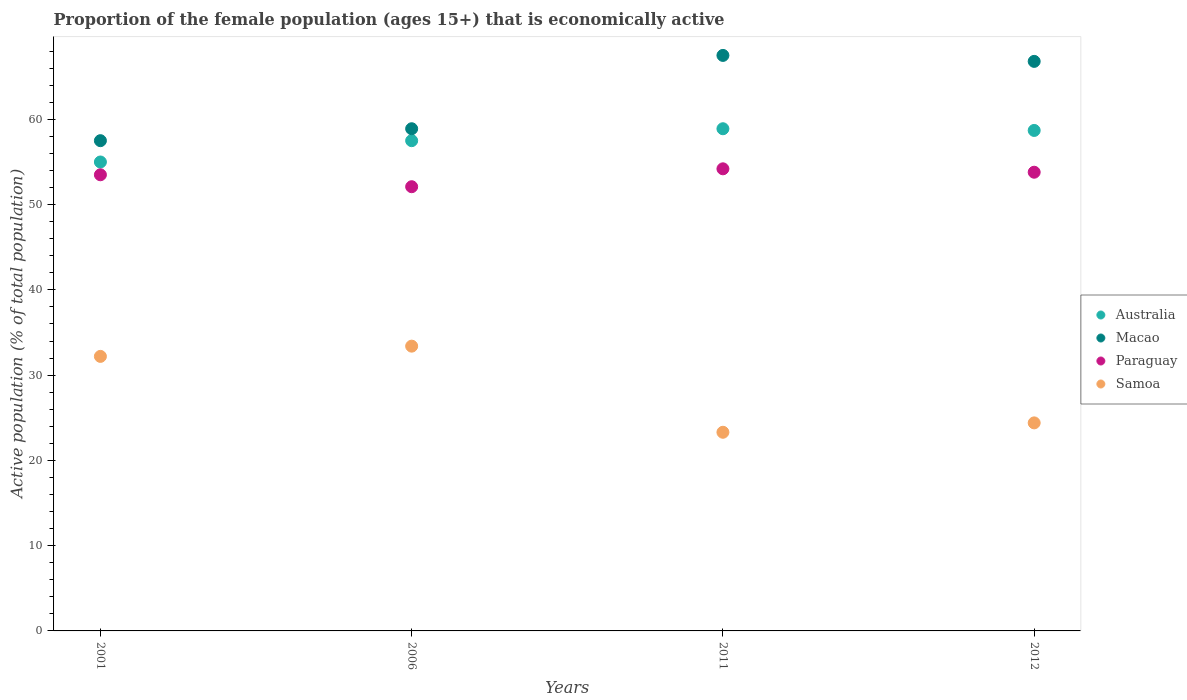How many different coloured dotlines are there?
Your answer should be very brief. 4. Is the number of dotlines equal to the number of legend labels?
Give a very brief answer. Yes. What is the proportion of the female population that is economically active in Samoa in 2006?
Ensure brevity in your answer.  33.4. Across all years, what is the maximum proportion of the female population that is economically active in Macao?
Your answer should be very brief. 67.5. Across all years, what is the minimum proportion of the female population that is economically active in Macao?
Make the answer very short. 57.5. What is the total proportion of the female population that is economically active in Paraguay in the graph?
Your answer should be compact. 213.6. What is the difference between the proportion of the female population that is economically active in Paraguay in 2006 and that in 2012?
Offer a very short reply. -1.7. What is the difference between the proportion of the female population that is economically active in Samoa in 2006 and the proportion of the female population that is economically active in Paraguay in 2001?
Your answer should be very brief. -20.1. What is the average proportion of the female population that is economically active in Paraguay per year?
Provide a succinct answer. 53.4. In the year 2011, what is the difference between the proportion of the female population that is economically active in Macao and proportion of the female population that is economically active in Australia?
Provide a short and direct response. 8.6. What is the ratio of the proportion of the female population that is economically active in Australia in 2006 to that in 2012?
Offer a very short reply. 0.98. Is the difference between the proportion of the female population that is economically active in Macao in 2001 and 2006 greater than the difference between the proportion of the female population that is economically active in Australia in 2001 and 2006?
Keep it short and to the point. Yes. What is the difference between the highest and the second highest proportion of the female population that is economically active in Samoa?
Your answer should be very brief. 1.2. What is the difference between the highest and the lowest proportion of the female population that is economically active in Samoa?
Your response must be concise. 10.1. Is it the case that in every year, the sum of the proportion of the female population that is economically active in Paraguay and proportion of the female population that is economically active in Macao  is greater than the sum of proportion of the female population that is economically active in Australia and proportion of the female population that is economically active in Samoa?
Provide a succinct answer. No. Does the proportion of the female population that is economically active in Samoa monotonically increase over the years?
Provide a succinct answer. No. Is the proportion of the female population that is economically active in Paraguay strictly greater than the proportion of the female population that is economically active in Australia over the years?
Offer a very short reply. No. Is the proportion of the female population that is economically active in Paraguay strictly less than the proportion of the female population that is economically active in Australia over the years?
Make the answer very short. Yes. How many years are there in the graph?
Your response must be concise. 4. What is the difference between two consecutive major ticks on the Y-axis?
Your response must be concise. 10. Are the values on the major ticks of Y-axis written in scientific E-notation?
Give a very brief answer. No. Where does the legend appear in the graph?
Your answer should be compact. Center right. How many legend labels are there?
Provide a succinct answer. 4. What is the title of the graph?
Your answer should be compact. Proportion of the female population (ages 15+) that is economically active. What is the label or title of the X-axis?
Offer a terse response. Years. What is the label or title of the Y-axis?
Your response must be concise. Active population (% of total population). What is the Active population (% of total population) in Australia in 2001?
Provide a succinct answer. 55. What is the Active population (% of total population) in Macao in 2001?
Provide a short and direct response. 57.5. What is the Active population (% of total population) of Paraguay in 2001?
Keep it short and to the point. 53.5. What is the Active population (% of total population) of Samoa in 2001?
Your answer should be very brief. 32.2. What is the Active population (% of total population) of Australia in 2006?
Provide a succinct answer. 57.5. What is the Active population (% of total population) in Macao in 2006?
Offer a terse response. 58.9. What is the Active population (% of total population) of Paraguay in 2006?
Provide a succinct answer. 52.1. What is the Active population (% of total population) of Samoa in 2006?
Make the answer very short. 33.4. What is the Active population (% of total population) of Australia in 2011?
Make the answer very short. 58.9. What is the Active population (% of total population) in Macao in 2011?
Make the answer very short. 67.5. What is the Active population (% of total population) in Paraguay in 2011?
Offer a very short reply. 54.2. What is the Active population (% of total population) of Samoa in 2011?
Your answer should be compact. 23.3. What is the Active population (% of total population) of Australia in 2012?
Ensure brevity in your answer.  58.7. What is the Active population (% of total population) of Macao in 2012?
Give a very brief answer. 66.8. What is the Active population (% of total population) of Paraguay in 2012?
Provide a succinct answer. 53.8. What is the Active population (% of total population) of Samoa in 2012?
Your answer should be compact. 24.4. Across all years, what is the maximum Active population (% of total population) in Australia?
Provide a short and direct response. 58.9. Across all years, what is the maximum Active population (% of total population) in Macao?
Your response must be concise. 67.5. Across all years, what is the maximum Active population (% of total population) of Paraguay?
Your answer should be very brief. 54.2. Across all years, what is the maximum Active population (% of total population) in Samoa?
Offer a very short reply. 33.4. Across all years, what is the minimum Active population (% of total population) in Macao?
Ensure brevity in your answer.  57.5. Across all years, what is the minimum Active population (% of total population) of Paraguay?
Offer a very short reply. 52.1. Across all years, what is the minimum Active population (% of total population) in Samoa?
Offer a terse response. 23.3. What is the total Active population (% of total population) in Australia in the graph?
Make the answer very short. 230.1. What is the total Active population (% of total population) in Macao in the graph?
Keep it short and to the point. 250.7. What is the total Active population (% of total population) of Paraguay in the graph?
Offer a terse response. 213.6. What is the total Active population (% of total population) of Samoa in the graph?
Provide a succinct answer. 113.3. What is the difference between the Active population (% of total population) of Macao in 2001 and that in 2011?
Your answer should be very brief. -10. What is the difference between the Active population (% of total population) in Samoa in 2001 and that in 2011?
Make the answer very short. 8.9. What is the difference between the Active population (% of total population) of Australia in 2001 and that in 2012?
Make the answer very short. -3.7. What is the difference between the Active population (% of total population) in Macao in 2006 and that in 2011?
Keep it short and to the point. -8.6. What is the difference between the Active population (% of total population) in Samoa in 2006 and that in 2011?
Offer a terse response. 10.1. What is the difference between the Active population (% of total population) in Australia in 2006 and that in 2012?
Your answer should be very brief. -1.2. What is the difference between the Active population (% of total population) in Macao in 2006 and that in 2012?
Keep it short and to the point. -7.9. What is the difference between the Active population (% of total population) of Australia in 2001 and the Active population (% of total population) of Paraguay in 2006?
Your response must be concise. 2.9. What is the difference between the Active population (% of total population) in Australia in 2001 and the Active population (% of total population) in Samoa in 2006?
Your answer should be compact. 21.6. What is the difference between the Active population (% of total population) of Macao in 2001 and the Active population (% of total population) of Paraguay in 2006?
Ensure brevity in your answer.  5.4. What is the difference between the Active population (% of total population) in Macao in 2001 and the Active population (% of total population) in Samoa in 2006?
Offer a very short reply. 24.1. What is the difference between the Active population (% of total population) in Paraguay in 2001 and the Active population (% of total population) in Samoa in 2006?
Ensure brevity in your answer.  20.1. What is the difference between the Active population (% of total population) in Australia in 2001 and the Active population (% of total population) in Macao in 2011?
Make the answer very short. -12.5. What is the difference between the Active population (% of total population) of Australia in 2001 and the Active population (% of total population) of Samoa in 2011?
Provide a succinct answer. 31.7. What is the difference between the Active population (% of total population) of Macao in 2001 and the Active population (% of total population) of Samoa in 2011?
Your answer should be compact. 34.2. What is the difference between the Active population (% of total population) of Paraguay in 2001 and the Active population (% of total population) of Samoa in 2011?
Your answer should be very brief. 30.2. What is the difference between the Active population (% of total population) of Australia in 2001 and the Active population (% of total population) of Macao in 2012?
Ensure brevity in your answer.  -11.8. What is the difference between the Active population (% of total population) in Australia in 2001 and the Active population (% of total population) in Paraguay in 2012?
Provide a short and direct response. 1.2. What is the difference between the Active population (% of total population) of Australia in 2001 and the Active population (% of total population) of Samoa in 2012?
Ensure brevity in your answer.  30.6. What is the difference between the Active population (% of total population) of Macao in 2001 and the Active population (% of total population) of Samoa in 2012?
Make the answer very short. 33.1. What is the difference between the Active population (% of total population) of Paraguay in 2001 and the Active population (% of total population) of Samoa in 2012?
Offer a terse response. 29.1. What is the difference between the Active population (% of total population) in Australia in 2006 and the Active population (% of total population) in Macao in 2011?
Ensure brevity in your answer.  -10. What is the difference between the Active population (% of total population) of Australia in 2006 and the Active population (% of total population) of Samoa in 2011?
Your answer should be compact. 34.2. What is the difference between the Active population (% of total population) of Macao in 2006 and the Active population (% of total population) of Samoa in 2011?
Give a very brief answer. 35.6. What is the difference between the Active population (% of total population) of Paraguay in 2006 and the Active population (% of total population) of Samoa in 2011?
Make the answer very short. 28.8. What is the difference between the Active population (% of total population) in Australia in 2006 and the Active population (% of total population) in Macao in 2012?
Provide a short and direct response. -9.3. What is the difference between the Active population (% of total population) in Australia in 2006 and the Active population (% of total population) in Samoa in 2012?
Ensure brevity in your answer.  33.1. What is the difference between the Active population (% of total population) of Macao in 2006 and the Active population (% of total population) of Paraguay in 2012?
Keep it short and to the point. 5.1. What is the difference between the Active population (% of total population) of Macao in 2006 and the Active population (% of total population) of Samoa in 2012?
Offer a very short reply. 34.5. What is the difference between the Active population (% of total population) of Paraguay in 2006 and the Active population (% of total population) of Samoa in 2012?
Your response must be concise. 27.7. What is the difference between the Active population (% of total population) in Australia in 2011 and the Active population (% of total population) in Samoa in 2012?
Make the answer very short. 34.5. What is the difference between the Active population (% of total population) of Macao in 2011 and the Active population (% of total population) of Paraguay in 2012?
Offer a very short reply. 13.7. What is the difference between the Active population (% of total population) in Macao in 2011 and the Active population (% of total population) in Samoa in 2012?
Keep it short and to the point. 43.1. What is the difference between the Active population (% of total population) in Paraguay in 2011 and the Active population (% of total population) in Samoa in 2012?
Your answer should be compact. 29.8. What is the average Active population (% of total population) in Australia per year?
Offer a terse response. 57.52. What is the average Active population (% of total population) in Macao per year?
Give a very brief answer. 62.67. What is the average Active population (% of total population) in Paraguay per year?
Offer a terse response. 53.4. What is the average Active population (% of total population) in Samoa per year?
Your answer should be compact. 28.32. In the year 2001, what is the difference between the Active population (% of total population) of Australia and Active population (% of total population) of Macao?
Ensure brevity in your answer.  -2.5. In the year 2001, what is the difference between the Active population (% of total population) of Australia and Active population (% of total population) of Samoa?
Your answer should be very brief. 22.8. In the year 2001, what is the difference between the Active population (% of total population) in Macao and Active population (% of total population) in Samoa?
Offer a terse response. 25.3. In the year 2001, what is the difference between the Active population (% of total population) in Paraguay and Active population (% of total population) in Samoa?
Offer a terse response. 21.3. In the year 2006, what is the difference between the Active population (% of total population) of Australia and Active population (% of total population) of Samoa?
Keep it short and to the point. 24.1. In the year 2006, what is the difference between the Active population (% of total population) of Paraguay and Active population (% of total population) of Samoa?
Keep it short and to the point. 18.7. In the year 2011, what is the difference between the Active population (% of total population) in Australia and Active population (% of total population) in Macao?
Your answer should be compact. -8.6. In the year 2011, what is the difference between the Active population (% of total population) in Australia and Active population (% of total population) in Paraguay?
Offer a very short reply. 4.7. In the year 2011, what is the difference between the Active population (% of total population) in Australia and Active population (% of total population) in Samoa?
Keep it short and to the point. 35.6. In the year 2011, what is the difference between the Active population (% of total population) of Macao and Active population (% of total population) of Samoa?
Provide a short and direct response. 44.2. In the year 2011, what is the difference between the Active population (% of total population) in Paraguay and Active population (% of total population) in Samoa?
Ensure brevity in your answer.  30.9. In the year 2012, what is the difference between the Active population (% of total population) of Australia and Active population (% of total population) of Samoa?
Your answer should be compact. 34.3. In the year 2012, what is the difference between the Active population (% of total population) of Macao and Active population (% of total population) of Samoa?
Your answer should be very brief. 42.4. In the year 2012, what is the difference between the Active population (% of total population) of Paraguay and Active population (% of total population) of Samoa?
Your answer should be compact. 29.4. What is the ratio of the Active population (% of total population) of Australia in 2001 to that in 2006?
Give a very brief answer. 0.96. What is the ratio of the Active population (% of total population) in Macao in 2001 to that in 2006?
Offer a very short reply. 0.98. What is the ratio of the Active population (% of total population) of Paraguay in 2001 to that in 2006?
Your answer should be very brief. 1.03. What is the ratio of the Active population (% of total population) in Samoa in 2001 to that in 2006?
Ensure brevity in your answer.  0.96. What is the ratio of the Active population (% of total population) of Australia in 2001 to that in 2011?
Offer a terse response. 0.93. What is the ratio of the Active population (% of total population) in Macao in 2001 to that in 2011?
Offer a terse response. 0.85. What is the ratio of the Active population (% of total population) of Paraguay in 2001 to that in 2011?
Ensure brevity in your answer.  0.99. What is the ratio of the Active population (% of total population) in Samoa in 2001 to that in 2011?
Your answer should be very brief. 1.38. What is the ratio of the Active population (% of total population) of Australia in 2001 to that in 2012?
Your answer should be compact. 0.94. What is the ratio of the Active population (% of total population) in Macao in 2001 to that in 2012?
Provide a succinct answer. 0.86. What is the ratio of the Active population (% of total population) of Paraguay in 2001 to that in 2012?
Give a very brief answer. 0.99. What is the ratio of the Active population (% of total population) in Samoa in 2001 to that in 2012?
Ensure brevity in your answer.  1.32. What is the ratio of the Active population (% of total population) in Australia in 2006 to that in 2011?
Keep it short and to the point. 0.98. What is the ratio of the Active population (% of total population) of Macao in 2006 to that in 2011?
Your answer should be very brief. 0.87. What is the ratio of the Active population (% of total population) in Paraguay in 2006 to that in 2011?
Keep it short and to the point. 0.96. What is the ratio of the Active population (% of total population) in Samoa in 2006 to that in 2011?
Ensure brevity in your answer.  1.43. What is the ratio of the Active population (% of total population) in Australia in 2006 to that in 2012?
Provide a succinct answer. 0.98. What is the ratio of the Active population (% of total population) in Macao in 2006 to that in 2012?
Your response must be concise. 0.88. What is the ratio of the Active population (% of total population) of Paraguay in 2006 to that in 2012?
Your answer should be very brief. 0.97. What is the ratio of the Active population (% of total population) in Samoa in 2006 to that in 2012?
Your answer should be compact. 1.37. What is the ratio of the Active population (% of total population) in Macao in 2011 to that in 2012?
Make the answer very short. 1.01. What is the ratio of the Active population (% of total population) of Paraguay in 2011 to that in 2012?
Offer a terse response. 1.01. What is the ratio of the Active population (% of total population) in Samoa in 2011 to that in 2012?
Provide a succinct answer. 0.95. What is the difference between the highest and the second highest Active population (% of total population) in Australia?
Offer a very short reply. 0.2. What is the difference between the highest and the second highest Active population (% of total population) in Macao?
Your answer should be very brief. 0.7. What is the difference between the highest and the lowest Active population (% of total population) of Australia?
Make the answer very short. 3.9. What is the difference between the highest and the lowest Active population (% of total population) in Samoa?
Provide a succinct answer. 10.1. 